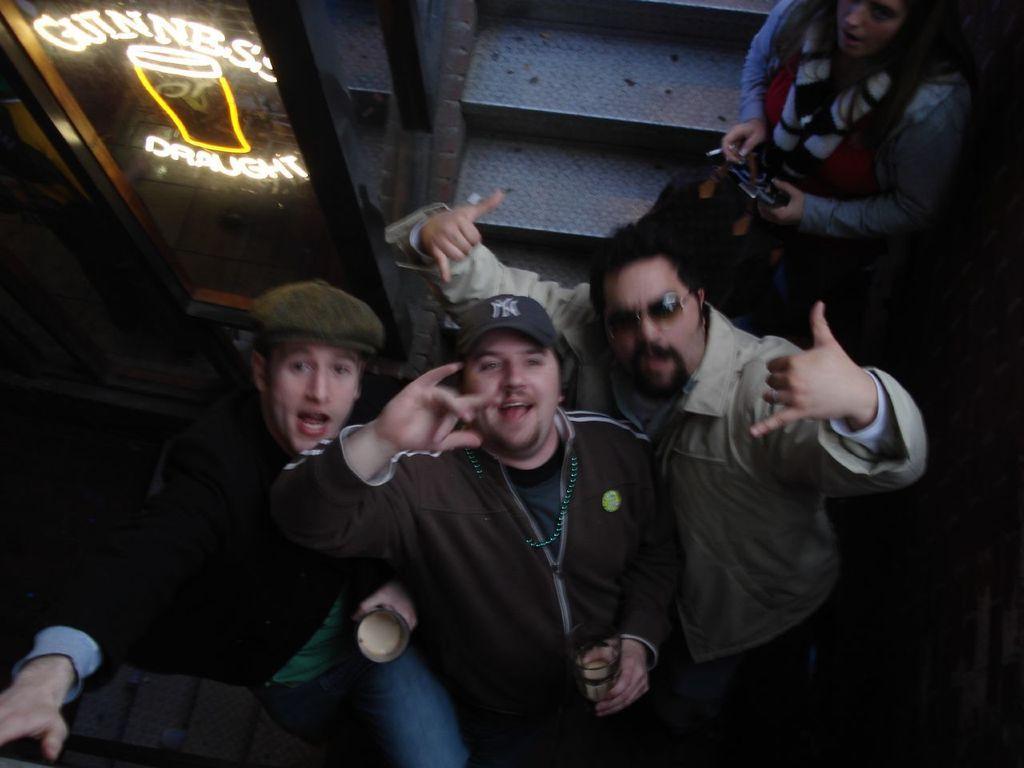Could you give a brief overview of what you see in this image? In this image there are persons sitting and smiling. On the top right there is a woman holding a black colour object in her hand, and on the left side there is a glass and on the glass there is some text written on it. 